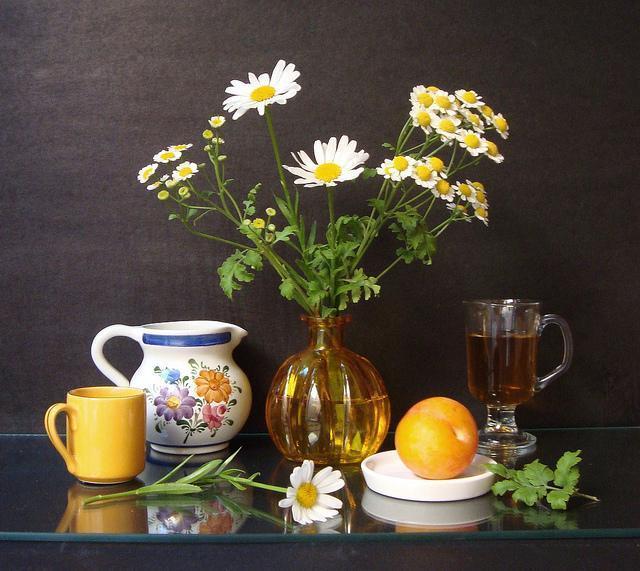How many cups are visible?
Give a very brief answer. 2. 